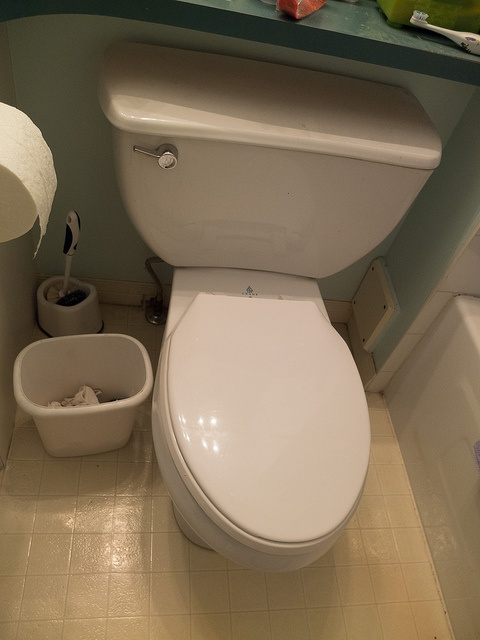Describe the objects in this image and their specific colors. I can see toilet in black, tan, and gray tones and toothbrush in black, gray, and tan tones in this image. 